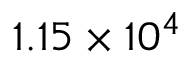<formula> <loc_0><loc_0><loc_500><loc_500>1 . 1 5 \times 1 0 ^ { 4 }</formula> 